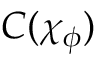Convert formula to latex. <formula><loc_0><loc_0><loc_500><loc_500>C ( \chi _ { \phi } )</formula> 